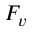Convert formula to latex. <formula><loc_0><loc_0><loc_500><loc_500>F _ { v }</formula> 